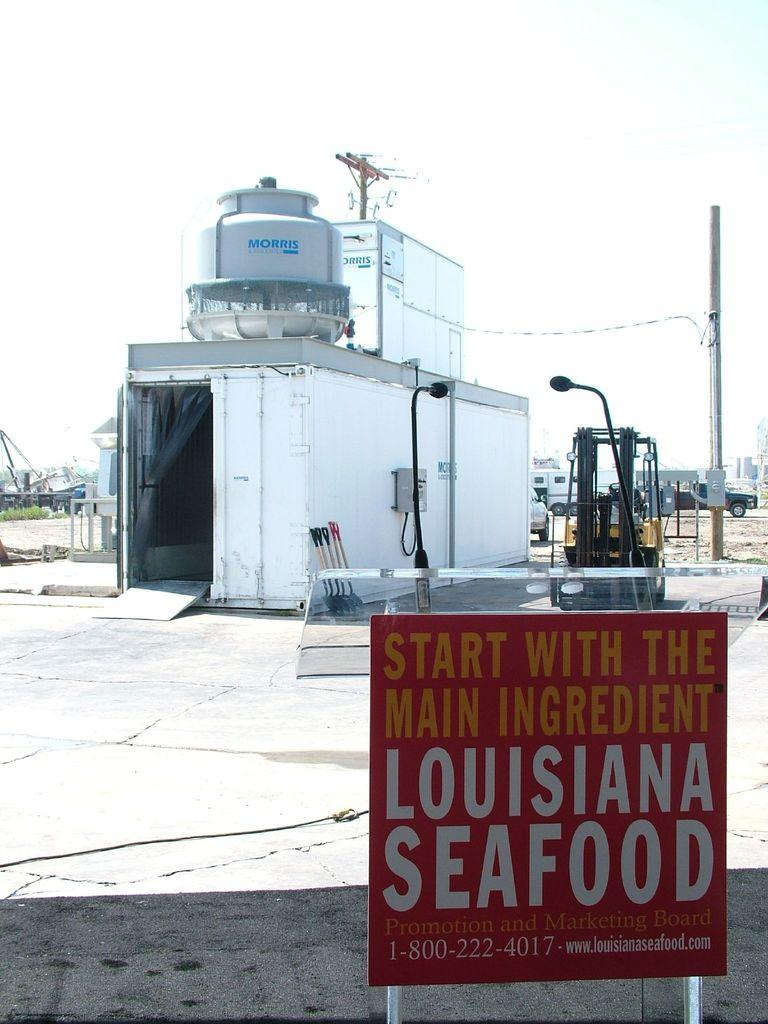Provide a one-sentence caption for the provided image. A small red sign advertises the goodness of Louisiana seafood. 